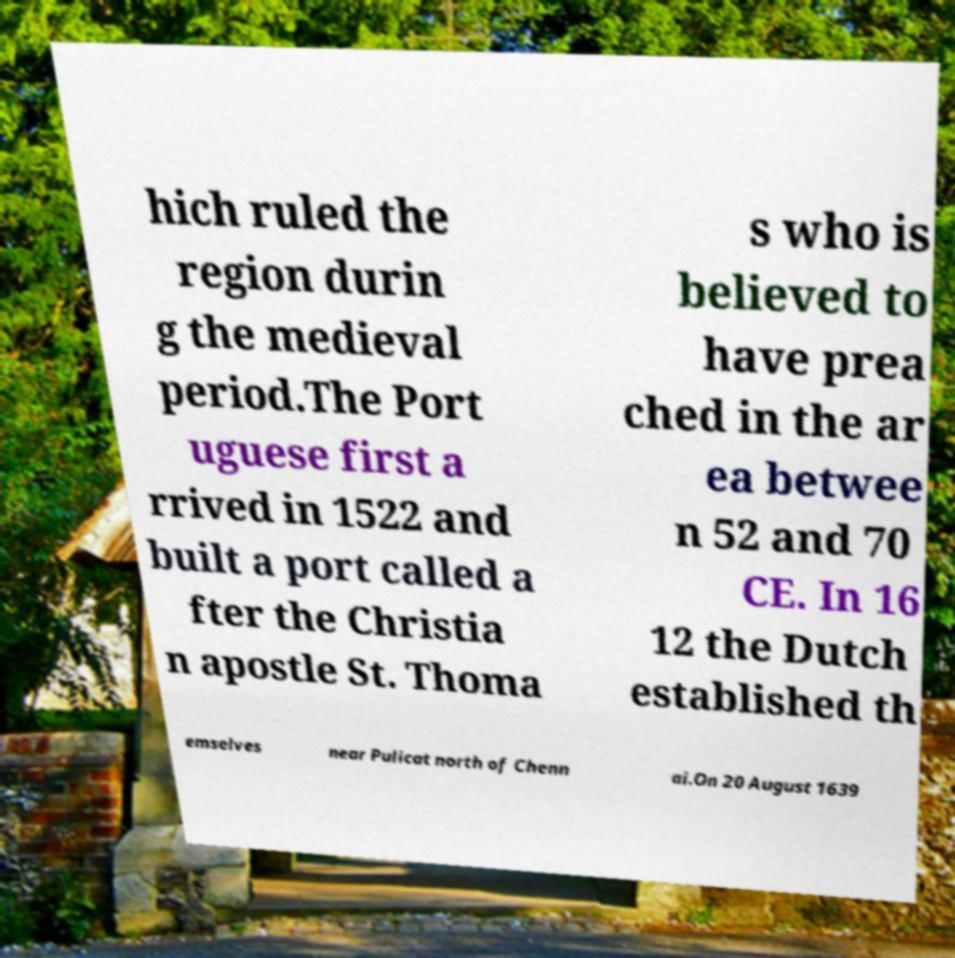Please identify and transcribe the text found in this image. hich ruled the region durin g the medieval period.The Port uguese first a rrived in 1522 and built a port called a fter the Christia n apostle St. Thoma s who is believed to have prea ched in the ar ea betwee n 52 and 70 CE. In 16 12 the Dutch established th emselves near Pulicat north of Chenn ai.On 20 August 1639 